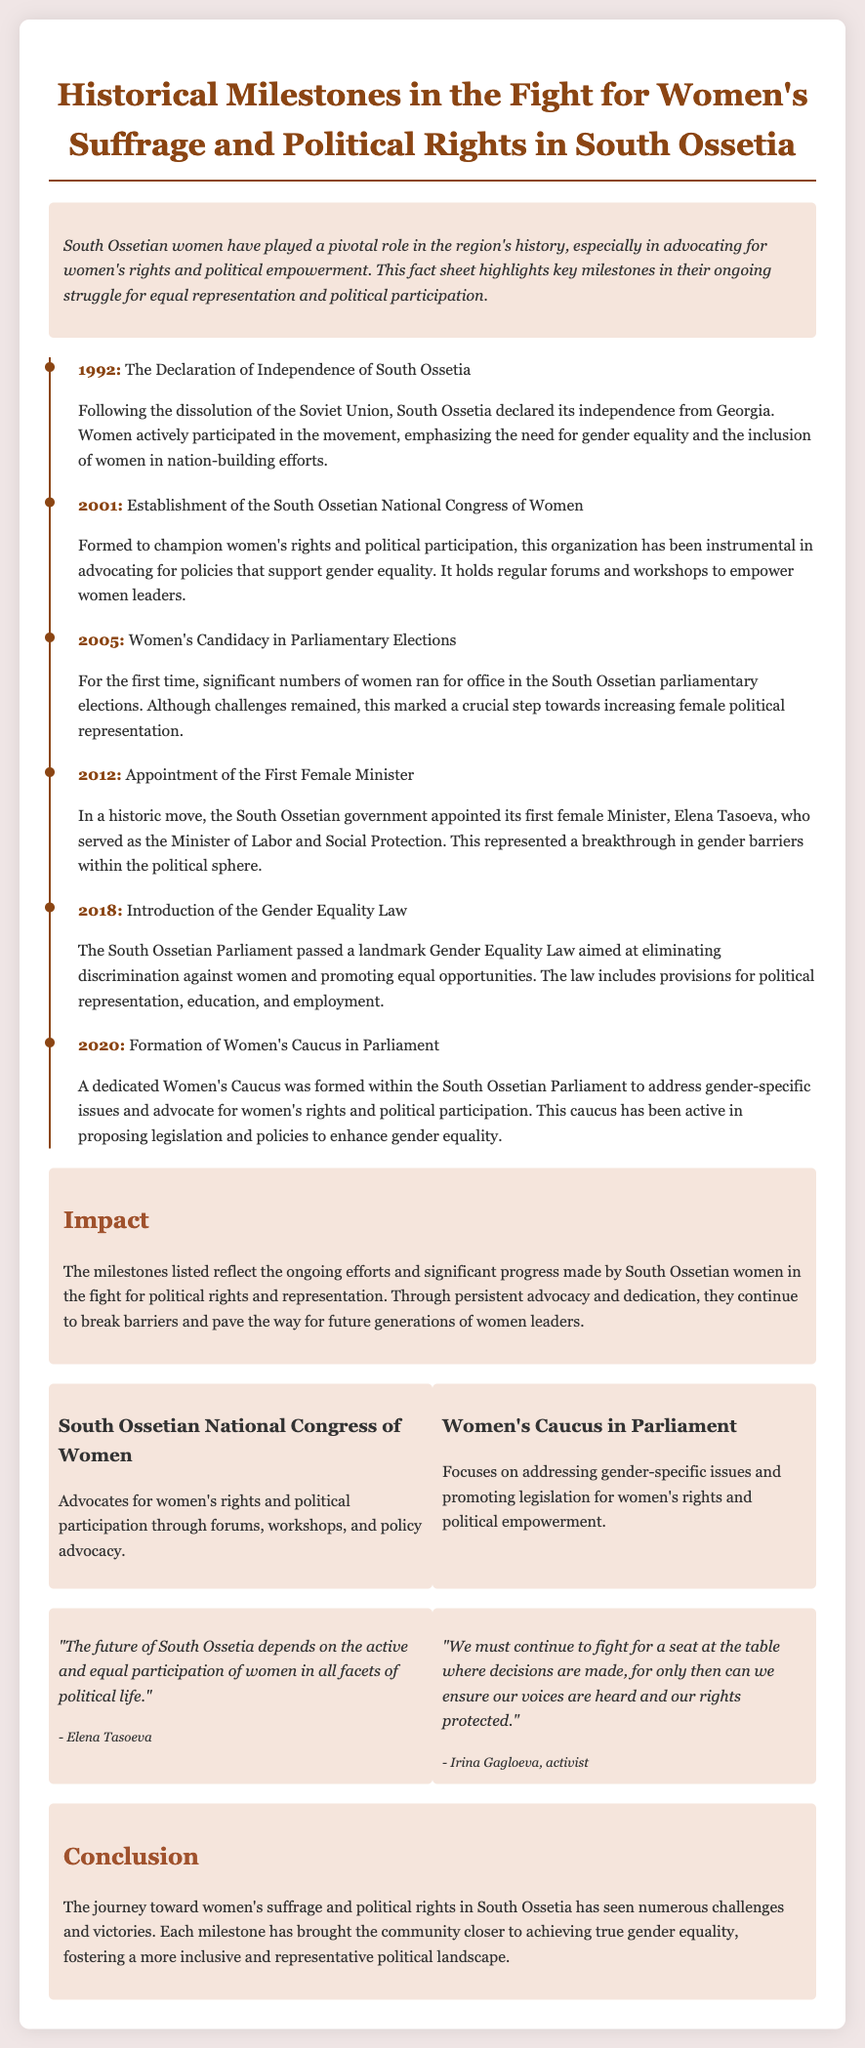What year did the South Ossetian Declaration of Independence occur? The document lists 1992 as the year when South Ossetia declared its independence from Georgia.
Answer: 1992 Who was the first female minister appointed in South Ossetia? The document states that Elena Tasoeva was the first female Minister, specifically of Labor and Social Protection.
Answer: Elena Tasoeva What significant law was introduced in South Ossetia in 2018? According to the document, the Gender Equality Law was passed in 2018 to eliminate discrimination against women.
Answer: Gender Equality Law How many women ran for office in the 2005 parliamentary elections? The document mentions that significant numbers of women ran for office for the first time in the 2005 parliamentary elections, but does not specify a number.
Answer: Significant numbers What organization was established in 2001 to advocate for women's rights? The South Ossetian National Congress of Women was formed in 2001 for this purpose.
Answer: South Ossetian National Congress of Women What is the primary function of the Women's Caucus in Parliament? The Women's Caucus focuses on addressing gender-specific issues and promoting women's rights and political empowerment.
Answer: Addressing gender-specific issues Which significant milestone took place in 2020? The formation of a dedicated Women's Caucus in Parliament occurred in 2020 to advocate for women's rights.
Answer: Formation of Women's Caucus What is the tone of the quotes provided in the document? The quotes reflect a motivational and empowering tone regarding women's participation in politics in South Ossetia.
Answer: Motivational and empowering 